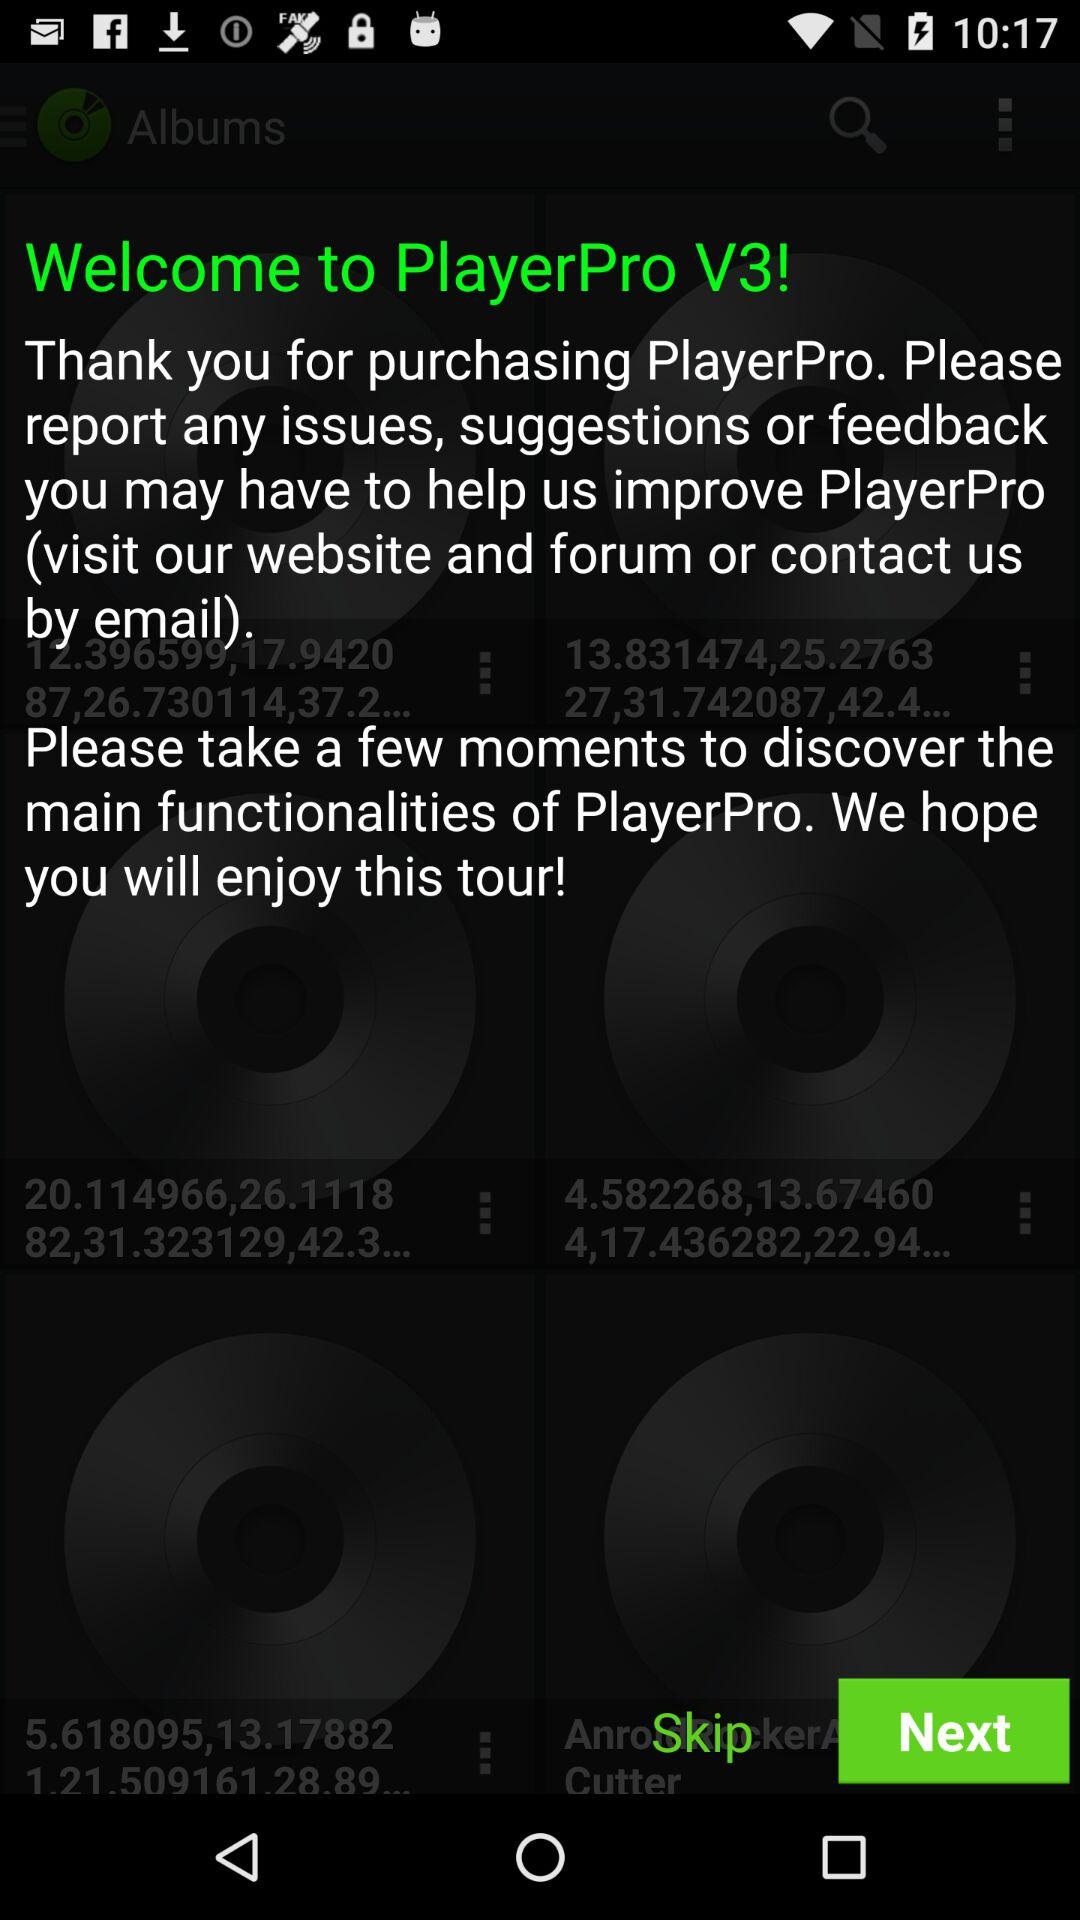What is the application name? The application name is "PlayerPro". 